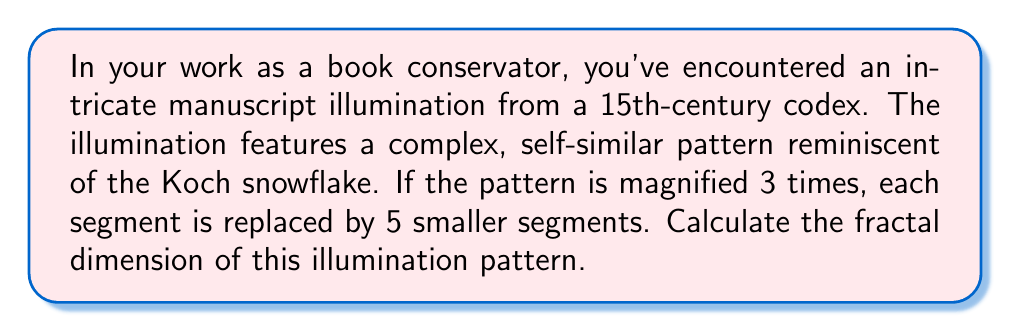Help me with this question. To calculate the fractal dimension of this illumination pattern, we'll use the box-counting dimension formula, which is a common method for estimating fractal dimensions.

The general formula for fractal dimension $D$ is:

$$D = \frac{\log N}{\log S}$$

Where:
$N$ is the number of self-similar pieces
$S$ is the scaling factor

In this case:
$N = 5$ (each segment is replaced by 5 smaller segments)
$S = 3$ (the pattern is magnified 3 times)

Let's substitute these values into the formula:

$$D = \frac{\log 5}{\log 3}$$

Using a calculator or logarithm tables:

$$D = \frac{\log 5}{\log 3} \approx \frac{0.69897}{0.47712} \approx 1.4649$$

This value is between 1 (dimension of a line) and 2 (dimension of a plane), which is typical for fractal patterns in 2D space.

To interpret this result:
1. A dimension greater than 1 indicates that the pattern is more complex than a simple line.
2. The closer the value is to 2, the more the pattern fills the 2D space.
3. This fractal dimension (≈1.4649) suggests a moderately complex pattern that partially fills the space, similar to the Koch snowflake (which has a dimension of approximately 1.2619).
Answer: The fractal dimension of the manuscript illumination pattern is approximately 1.4649. 